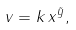<formula> <loc_0><loc_0><loc_500><loc_500>v = k \, x ^ { \tilde { y } } ,</formula> 